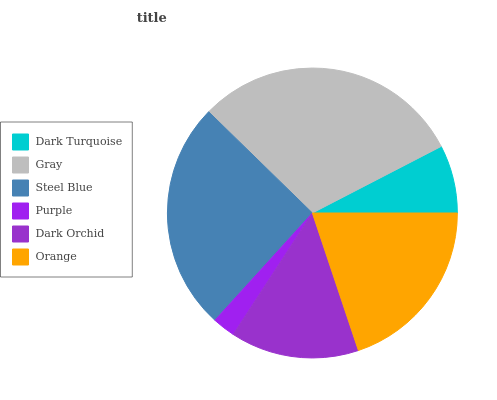Is Purple the minimum?
Answer yes or no. Yes. Is Gray the maximum?
Answer yes or no. Yes. Is Steel Blue the minimum?
Answer yes or no. No. Is Steel Blue the maximum?
Answer yes or no. No. Is Gray greater than Steel Blue?
Answer yes or no. Yes. Is Steel Blue less than Gray?
Answer yes or no. Yes. Is Steel Blue greater than Gray?
Answer yes or no. No. Is Gray less than Steel Blue?
Answer yes or no. No. Is Orange the high median?
Answer yes or no. Yes. Is Dark Orchid the low median?
Answer yes or no. Yes. Is Gray the high median?
Answer yes or no. No. Is Gray the low median?
Answer yes or no. No. 